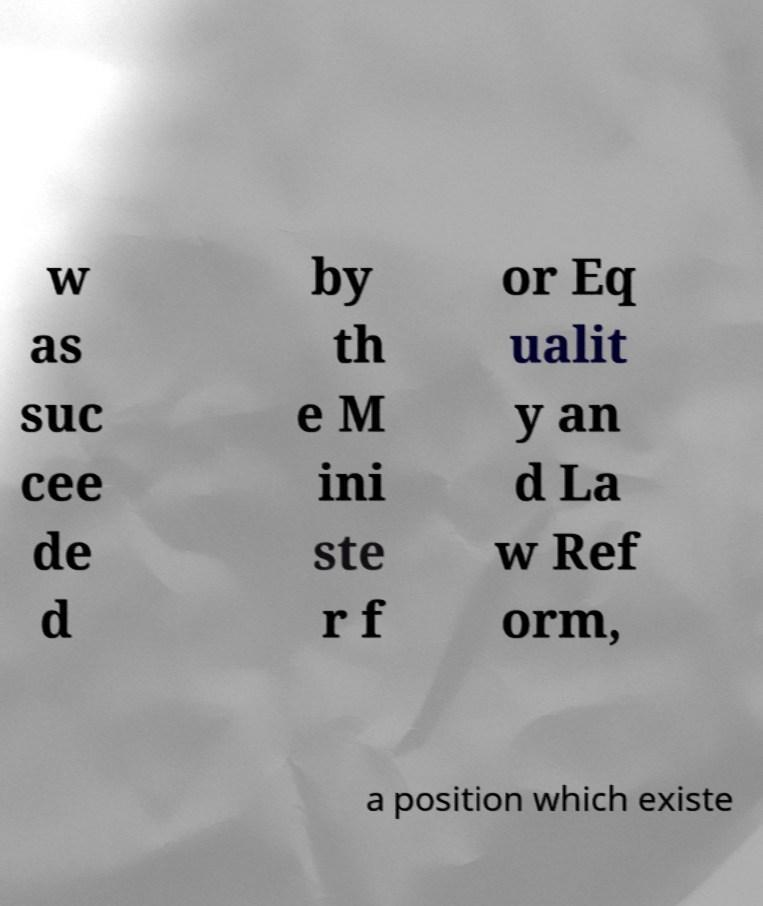Please read and relay the text visible in this image. What does it say? w as suc cee de d by th e M ini ste r f or Eq ualit y an d La w Ref orm, a position which existe 